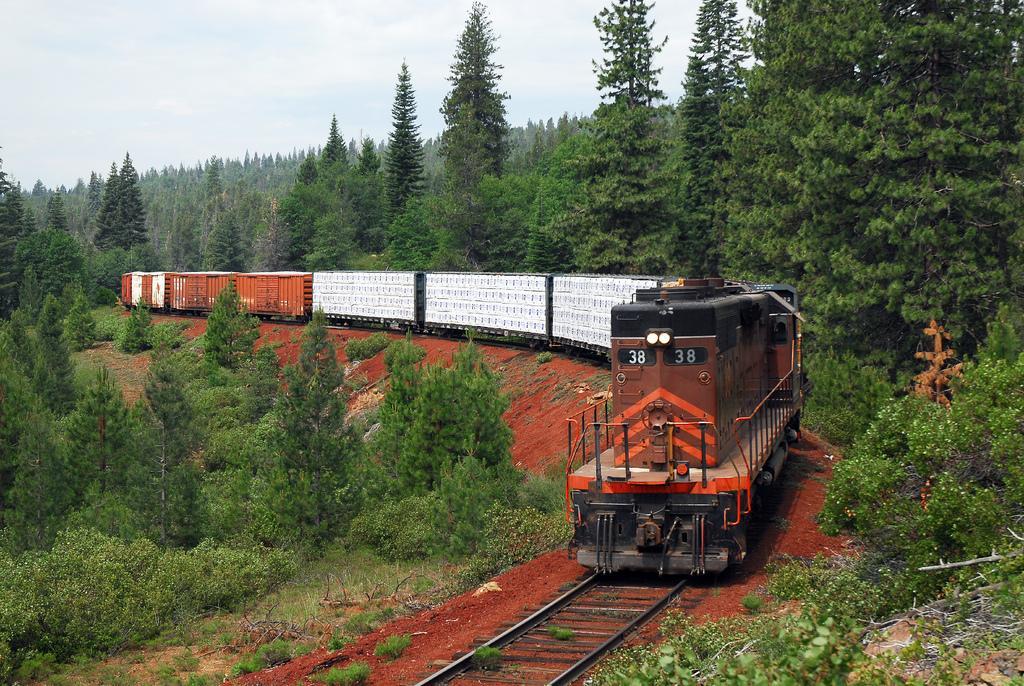In one or two sentences, can you explain what this image depicts? There is a train on the right side of the image and there is greenery on both the sides. There is sky at the top side. 